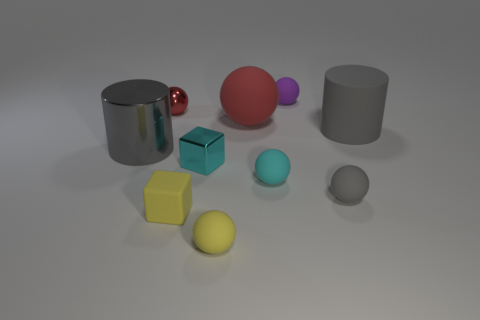Subtract all cyan spheres. How many spheres are left? 5 Subtract all small purple rubber spheres. How many spheres are left? 5 Subtract all brown spheres. Subtract all red cylinders. How many spheres are left? 6 Subtract all spheres. How many objects are left? 4 Subtract all small shiny things. Subtract all large gray shiny things. How many objects are left? 7 Add 4 tiny shiny things. How many tiny shiny things are left? 6 Add 10 big cyan spheres. How many big cyan spheres exist? 10 Subtract 0 red cylinders. How many objects are left? 10 